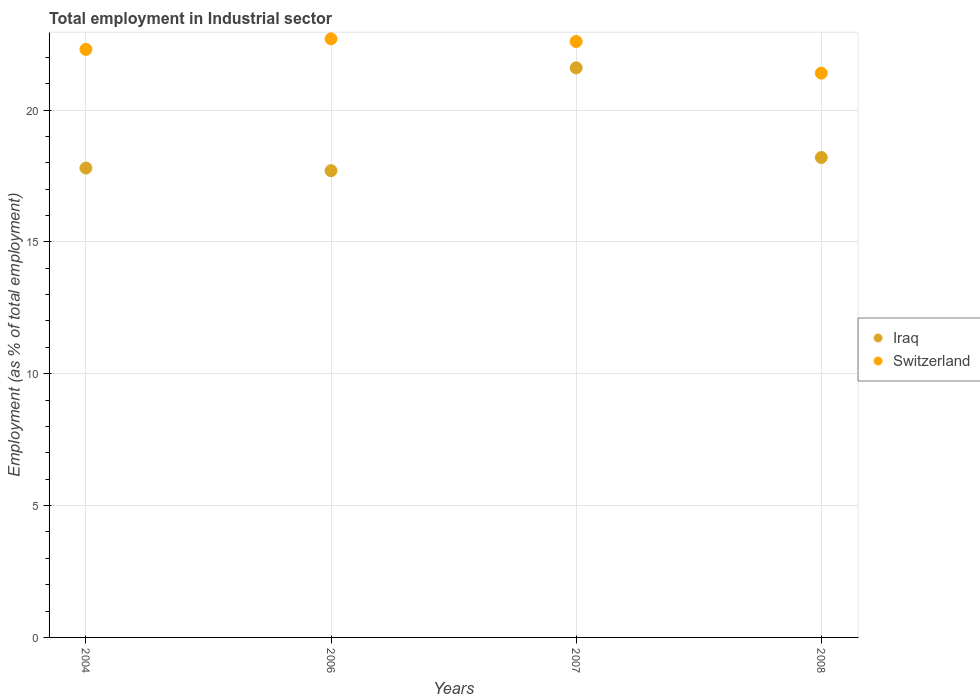What is the employment in industrial sector in Switzerland in 2007?
Ensure brevity in your answer.  22.6. Across all years, what is the maximum employment in industrial sector in Iraq?
Ensure brevity in your answer.  21.6. Across all years, what is the minimum employment in industrial sector in Switzerland?
Your answer should be very brief. 21.4. In which year was the employment in industrial sector in Iraq minimum?
Keep it short and to the point. 2006. What is the total employment in industrial sector in Iraq in the graph?
Offer a very short reply. 75.3. What is the difference between the employment in industrial sector in Switzerland in 2007 and that in 2008?
Provide a succinct answer. 1.2. What is the difference between the employment in industrial sector in Switzerland in 2006 and the employment in industrial sector in Iraq in 2004?
Offer a terse response. 4.9. What is the average employment in industrial sector in Iraq per year?
Offer a terse response. 18.83. In how many years, is the employment in industrial sector in Iraq greater than 12 %?
Your answer should be very brief. 4. What is the ratio of the employment in industrial sector in Switzerland in 2004 to that in 2006?
Provide a short and direct response. 0.98. Is the employment in industrial sector in Switzerland in 2006 less than that in 2008?
Your answer should be compact. No. Is the difference between the employment in industrial sector in Iraq in 2007 and 2008 greater than the difference between the employment in industrial sector in Switzerland in 2007 and 2008?
Make the answer very short. Yes. What is the difference between the highest and the second highest employment in industrial sector in Iraq?
Provide a succinct answer. 3.4. What is the difference between the highest and the lowest employment in industrial sector in Switzerland?
Make the answer very short. 1.3. In how many years, is the employment in industrial sector in Switzerland greater than the average employment in industrial sector in Switzerland taken over all years?
Keep it short and to the point. 3. Is the sum of the employment in industrial sector in Iraq in 2004 and 2007 greater than the maximum employment in industrial sector in Switzerland across all years?
Offer a very short reply. Yes. Is the employment in industrial sector in Switzerland strictly greater than the employment in industrial sector in Iraq over the years?
Give a very brief answer. Yes. How many dotlines are there?
Make the answer very short. 2. Are the values on the major ticks of Y-axis written in scientific E-notation?
Provide a succinct answer. No. How many legend labels are there?
Make the answer very short. 2. What is the title of the graph?
Keep it short and to the point. Total employment in Industrial sector. Does "High income: nonOECD" appear as one of the legend labels in the graph?
Provide a short and direct response. No. What is the label or title of the X-axis?
Your answer should be very brief. Years. What is the label or title of the Y-axis?
Provide a succinct answer. Employment (as % of total employment). What is the Employment (as % of total employment) in Iraq in 2004?
Your answer should be very brief. 17.8. What is the Employment (as % of total employment) in Switzerland in 2004?
Offer a terse response. 22.3. What is the Employment (as % of total employment) in Iraq in 2006?
Offer a very short reply. 17.7. What is the Employment (as % of total employment) of Switzerland in 2006?
Your response must be concise. 22.7. What is the Employment (as % of total employment) in Iraq in 2007?
Provide a short and direct response. 21.6. What is the Employment (as % of total employment) of Switzerland in 2007?
Offer a very short reply. 22.6. What is the Employment (as % of total employment) in Iraq in 2008?
Keep it short and to the point. 18.2. What is the Employment (as % of total employment) in Switzerland in 2008?
Your answer should be compact. 21.4. Across all years, what is the maximum Employment (as % of total employment) of Iraq?
Make the answer very short. 21.6. Across all years, what is the maximum Employment (as % of total employment) of Switzerland?
Your response must be concise. 22.7. Across all years, what is the minimum Employment (as % of total employment) of Iraq?
Give a very brief answer. 17.7. Across all years, what is the minimum Employment (as % of total employment) of Switzerland?
Your answer should be very brief. 21.4. What is the total Employment (as % of total employment) of Iraq in the graph?
Your answer should be compact. 75.3. What is the total Employment (as % of total employment) in Switzerland in the graph?
Your response must be concise. 89. What is the difference between the Employment (as % of total employment) in Iraq in 2004 and that in 2006?
Ensure brevity in your answer.  0.1. What is the difference between the Employment (as % of total employment) in Switzerland in 2004 and that in 2006?
Your answer should be compact. -0.4. What is the difference between the Employment (as % of total employment) in Switzerland in 2004 and that in 2007?
Keep it short and to the point. -0.3. What is the difference between the Employment (as % of total employment) in Switzerland in 2004 and that in 2008?
Your answer should be compact. 0.9. What is the difference between the Employment (as % of total employment) of Iraq in 2006 and that in 2007?
Ensure brevity in your answer.  -3.9. What is the difference between the Employment (as % of total employment) of Switzerland in 2006 and that in 2007?
Provide a short and direct response. 0.1. What is the difference between the Employment (as % of total employment) in Switzerland in 2006 and that in 2008?
Your answer should be compact. 1.3. What is the difference between the Employment (as % of total employment) in Switzerland in 2007 and that in 2008?
Your answer should be compact. 1.2. What is the difference between the Employment (as % of total employment) in Iraq in 2004 and the Employment (as % of total employment) in Switzerland in 2006?
Make the answer very short. -4.9. What is the difference between the Employment (as % of total employment) of Iraq in 2004 and the Employment (as % of total employment) of Switzerland in 2008?
Your response must be concise. -3.6. What is the difference between the Employment (as % of total employment) in Iraq in 2006 and the Employment (as % of total employment) in Switzerland in 2007?
Your answer should be compact. -4.9. What is the average Employment (as % of total employment) of Iraq per year?
Provide a succinct answer. 18.82. What is the average Employment (as % of total employment) in Switzerland per year?
Make the answer very short. 22.25. In the year 2004, what is the difference between the Employment (as % of total employment) in Iraq and Employment (as % of total employment) in Switzerland?
Provide a short and direct response. -4.5. In the year 2007, what is the difference between the Employment (as % of total employment) of Iraq and Employment (as % of total employment) of Switzerland?
Make the answer very short. -1. In the year 2008, what is the difference between the Employment (as % of total employment) of Iraq and Employment (as % of total employment) of Switzerland?
Ensure brevity in your answer.  -3.2. What is the ratio of the Employment (as % of total employment) in Iraq in 2004 to that in 2006?
Give a very brief answer. 1.01. What is the ratio of the Employment (as % of total employment) of Switzerland in 2004 to that in 2006?
Provide a short and direct response. 0.98. What is the ratio of the Employment (as % of total employment) in Iraq in 2004 to that in 2007?
Give a very brief answer. 0.82. What is the ratio of the Employment (as % of total employment) of Switzerland in 2004 to that in 2007?
Ensure brevity in your answer.  0.99. What is the ratio of the Employment (as % of total employment) in Switzerland in 2004 to that in 2008?
Give a very brief answer. 1.04. What is the ratio of the Employment (as % of total employment) of Iraq in 2006 to that in 2007?
Ensure brevity in your answer.  0.82. What is the ratio of the Employment (as % of total employment) of Switzerland in 2006 to that in 2007?
Your answer should be very brief. 1. What is the ratio of the Employment (as % of total employment) in Iraq in 2006 to that in 2008?
Provide a succinct answer. 0.97. What is the ratio of the Employment (as % of total employment) of Switzerland in 2006 to that in 2008?
Provide a succinct answer. 1.06. What is the ratio of the Employment (as % of total employment) of Iraq in 2007 to that in 2008?
Give a very brief answer. 1.19. What is the ratio of the Employment (as % of total employment) in Switzerland in 2007 to that in 2008?
Keep it short and to the point. 1.06. What is the difference between the highest and the second highest Employment (as % of total employment) of Iraq?
Provide a short and direct response. 3.4. What is the difference between the highest and the lowest Employment (as % of total employment) of Switzerland?
Provide a succinct answer. 1.3. 